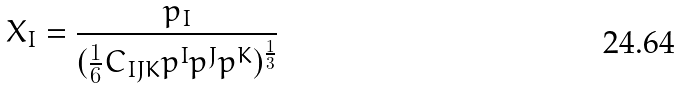Convert formula to latex. <formula><loc_0><loc_0><loc_500><loc_500>X _ { I } = \frac { p _ { I } } { ( \frac { 1 } { 6 } C _ { I J K } p ^ { I } p ^ { J } p ^ { K } ) ^ { \frac { 1 } { 3 } } }</formula> 